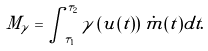Convert formula to latex. <formula><loc_0><loc_0><loc_500><loc_500>M _ { \gamma } = \int _ { \tau _ { 1 } } ^ { \tau _ { 2 } } \gamma \left ( u ( t ) \right ) \dot { m } ( t ) d t .</formula> 